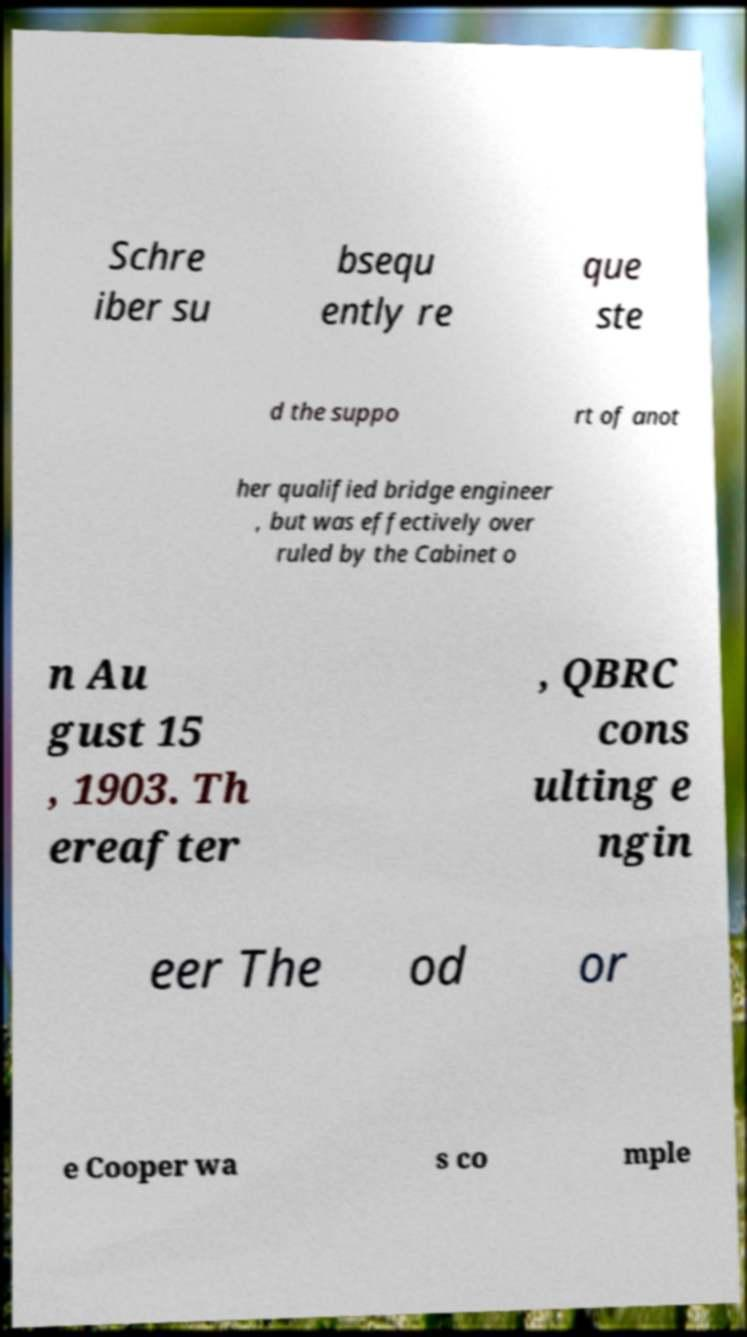Please read and relay the text visible in this image. What does it say? Schre iber su bsequ ently re que ste d the suppo rt of anot her qualified bridge engineer , but was effectively over ruled by the Cabinet o n Au gust 15 , 1903. Th ereafter , QBRC cons ulting e ngin eer The od or e Cooper wa s co mple 